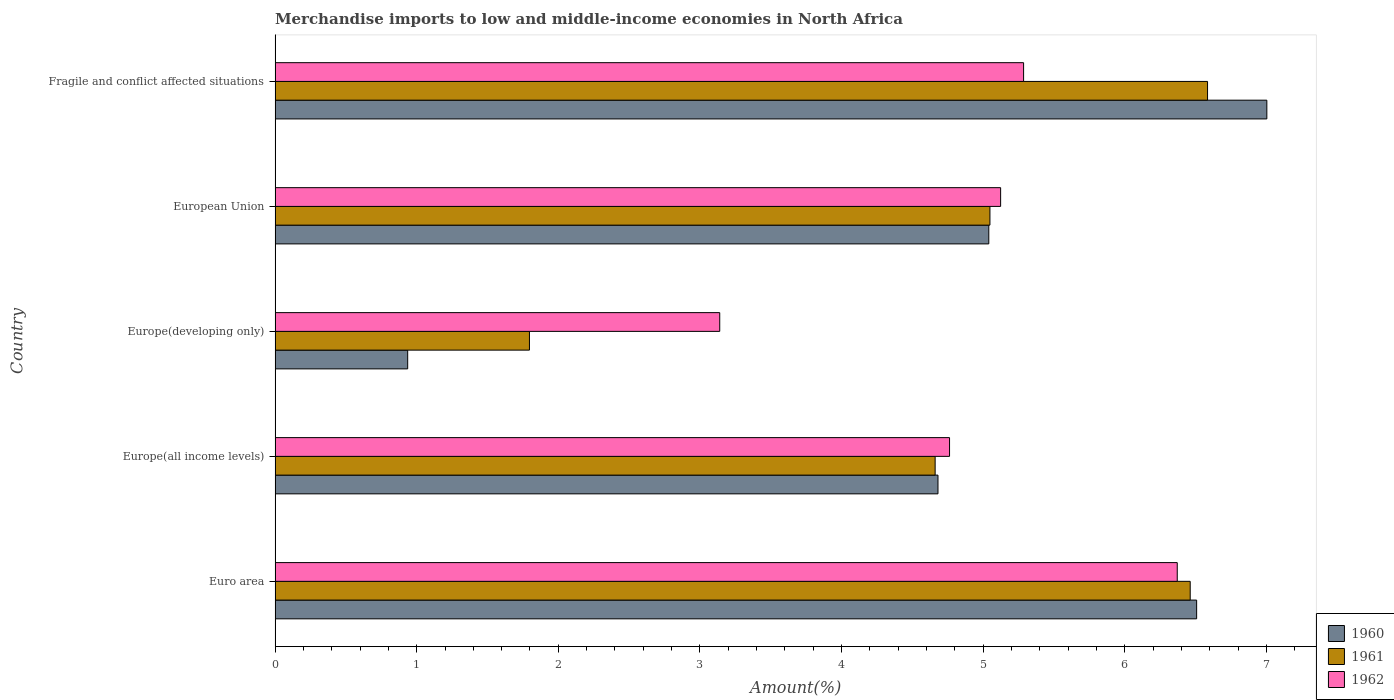How many different coloured bars are there?
Offer a very short reply. 3. How many groups of bars are there?
Your response must be concise. 5. Are the number of bars on each tick of the Y-axis equal?
Keep it short and to the point. Yes. What is the label of the 4th group of bars from the top?
Your response must be concise. Europe(all income levels). In how many cases, is the number of bars for a given country not equal to the number of legend labels?
Offer a terse response. 0. What is the percentage of amount earned from merchandise imports in 1962 in Fragile and conflict affected situations?
Ensure brevity in your answer.  5.29. Across all countries, what is the maximum percentage of amount earned from merchandise imports in 1960?
Your response must be concise. 7. Across all countries, what is the minimum percentage of amount earned from merchandise imports in 1962?
Your answer should be very brief. 3.14. In which country was the percentage of amount earned from merchandise imports in 1961 maximum?
Keep it short and to the point. Fragile and conflict affected situations. In which country was the percentage of amount earned from merchandise imports in 1961 minimum?
Make the answer very short. Europe(developing only). What is the total percentage of amount earned from merchandise imports in 1961 in the graph?
Provide a short and direct response. 24.55. What is the difference between the percentage of amount earned from merchandise imports in 1961 in Euro area and that in European Union?
Keep it short and to the point. 1.41. What is the difference between the percentage of amount earned from merchandise imports in 1962 in Euro area and the percentage of amount earned from merchandise imports in 1961 in Fragile and conflict affected situations?
Your response must be concise. -0.21. What is the average percentage of amount earned from merchandise imports in 1960 per country?
Your answer should be compact. 4.83. What is the difference between the percentage of amount earned from merchandise imports in 1961 and percentage of amount earned from merchandise imports in 1962 in Euro area?
Your answer should be very brief. 0.09. What is the ratio of the percentage of amount earned from merchandise imports in 1960 in Europe(developing only) to that in European Union?
Your answer should be very brief. 0.19. Is the percentage of amount earned from merchandise imports in 1961 in Europe(developing only) less than that in European Union?
Provide a short and direct response. Yes. What is the difference between the highest and the second highest percentage of amount earned from merchandise imports in 1962?
Give a very brief answer. 1.08. What is the difference between the highest and the lowest percentage of amount earned from merchandise imports in 1962?
Provide a short and direct response. 3.23. In how many countries, is the percentage of amount earned from merchandise imports in 1960 greater than the average percentage of amount earned from merchandise imports in 1960 taken over all countries?
Your response must be concise. 3. What does the 1st bar from the top in European Union represents?
Provide a succinct answer. 1962. What does the 2nd bar from the bottom in Europe(all income levels) represents?
Keep it short and to the point. 1961. Is it the case that in every country, the sum of the percentage of amount earned from merchandise imports in 1960 and percentage of amount earned from merchandise imports in 1961 is greater than the percentage of amount earned from merchandise imports in 1962?
Your answer should be very brief. No. What is the difference between two consecutive major ticks on the X-axis?
Make the answer very short. 1. Does the graph contain any zero values?
Your answer should be very brief. No. Where does the legend appear in the graph?
Make the answer very short. Bottom right. How are the legend labels stacked?
Your response must be concise. Vertical. What is the title of the graph?
Your answer should be very brief. Merchandise imports to low and middle-income economies in North Africa. Does "2000" appear as one of the legend labels in the graph?
Make the answer very short. No. What is the label or title of the X-axis?
Give a very brief answer. Amount(%). What is the Amount(%) of 1960 in Euro area?
Offer a terse response. 6.51. What is the Amount(%) of 1961 in Euro area?
Your answer should be very brief. 6.46. What is the Amount(%) of 1962 in Euro area?
Ensure brevity in your answer.  6.37. What is the Amount(%) in 1960 in Europe(all income levels)?
Ensure brevity in your answer.  4.68. What is the Amount(%) in 1961 in Europe(all income levels)?
Offer a very short reply. 4.66. What is the Amount(%) of 1962 in Europe(all income levels)?
Offer a very short reply. 4.76. What is the Amount(%) in 1960 in Europe(developing only)?
Ensure brevity in your answer.  0.94. What is the Amount(%) of 1961 in Europe(developing only)?
Provide a short and direct response. 1.8. What is the Amount(%) of 1962 in Europe(developing only)?
Make the answer very short. 3.14. What is the Amount(%) in 1960 in European Union?
Keep it short and to the point. 5.04. What is the Amount(%) of 1961 in European Union?
Your response must be concise. 5.05. What is the Amount(%) in 1962 in European Union?
Provide a short and direct response. 5.12. What is the Amount(%) of 1960 in Fragile and conflict affected situations?
Your response must be concise. 7. What is the Amount(%) of 1961 in Fragile and conflict affected situations?
Give a very brief answer. 6.58. What is the Amount(%) of 1962 in Fragile and conflict affected situations?
Keep it short and to the point. 5.29. Across all countries, what is the maximum Amount(%) of 1960?
Give a very brief answer. 7. Across all countries, what is the maximum Amount(%) of 1961?
Your response must be concise. 6.58. Across all countries, what is the maximum Amount(%) of 1962?
Make the answer very short. 6.37. Across all countries, what is the minimum Amount(%) of 1960?
Your response must be concise. 0.94. Across all countries, what is the minimum Amount(%) in 1961?
Give a very brief answer. 1.8. Across all countries, what is the minimum Amount(%) in 1962?
Make the answer very short. 3.14. What is the total Amount(%) in 1960 in the graph?
Give a very brief answer. 24.17. What is the total Amount(%) in 1961 in the graph?
Provide a short and direct response. 24.55. What is the total Amount(%) in 1962 in the graph?
Offer a terse response. 24.68. What is the difference between the Amount(%) in 1960 in Euro area and that in Europe(all income levels)?
Ensure brevity in your answer.  1.83. What is the difference between the Amount(%) in 1961 in Euro area and that in Europe(all income levels)?
Give a very brief answer. 1.8. What is the difference between the Amount(%) in 1962 in Euro area and that in Europe(all income levels)?
Keep it short and to the point. 1.61. What is the difference between the Amount(%) of 1960 in Euro area and that in Europe(developing only)?
Ensure brevity in your answer.  5.57. What is the difference between the Amount(%) in 1961 in Euro area and that in Europe(developing only)?
Offer a terse response. 4.67. What is the difference between the Amount(%) of 1962 in Euro area and that in Europe(developing only)?
Your answer should be compact. 3.23. What is the difference between the Amount(%) of 1960 in Euro area and that in European Union?
Your answer should be compact. 1.47. What is the difference between the Amount(%) in 1961 in Euro area and that in European Union?
Give a very brief answer. 1.41. What is the difference between the Amount(%) in 1962 in Euro area and that in European Union?
Make the answer very short. 1.25. What is the difference between the Amount(%) of 1960 in Euro area and that in Fragile and conflict affected situations?
Ensure brevity in your answer.  -0.5. What is the difference between the Amount(%) in 1961 in Euro area and that in Fragile and conflict affected situations?
Provide a short and direct response. -0.12. What is the difference between the Amount(%) of 1962 in Euro area and that in Fragile and conflict affected situations?
Provide a succinct answer. 1.08. What is the difference between the Amount(%) of 1960 in Europe(all income levels) and that in Europe(developing only)?
Keep it short and to the point. 3.74. What is the difference between the Amount(%) of 1961 in Europe(all income levels) and that in Europe(developing only)?
Your answer should be compact. 2.86. What is the difference between the Amount(%) of 1962 in Europe(all income levels) and that in Europe(developing only)?
Keep it short and to the point. 1.62. What is the difference between the Amount(%) in 1960 in Europe(all income levels) and that in European Union?
Provide a succinct answer. -0.36. What is the difference between the Amount(%) of 1961 in Europe(all income levels) and that in European Union?
Keep it short and to the point. -0.39. What is the difference between the Amount(%) in 1962 in Europe(all income levels) and that in European Union?
Make the answer very short. -0.36. What is the difference between the Amount(%) in 1960 in Europe(all income levels) and that in Fragile and conflict affected situations?
Make the answer very short. -2.32. What is the difference between the Amount(%) in 1961 in Europe(all income levels) and that in Fragile and conflict affected situations?
Give a very brief answer. -1.92. What is the difference between the Amount(%) in 1962 in Europe(all income levels) and that in Fragile and conflict affected situations?
Provide a succinct answer. -0.52. What is the difference between the Amount(%) in 1960 in Europe(developing only) and that in European Union?
Your answer should be very brief. -4.1. What is the difference between the Amount(%) in 1961 in Europe(developing only) and that in European Union?
Your answer should be very brief. -3.25. What is the difference between the Amount(%) in 1962 in Europe(developing only) and that in European Union?
Give a very brief answer. -1.98. What is the difference between the Amount(%) in 1960 in Europe(developing only) and that in Fragile and conflict affected situations?
Make the answer very short. -6.07. What is the difference between the Amount(%) in 1961 in Europe(developing only) and that in Fragile and conflict affected situations?
Your response must be concise. -4.79. What is the difference between the Amount(%) of 1962 in Europe(developing only) and that in Fragile and conflict affected situations?
Provide a short and direct response. -2.15. What is the difference between the Amount(%) in 1960 in European Union and that in Fragile and conflict affected situations?
Give a very brief answer. -1.96. What is the difference between the Amount(%) of 1961 in European Union and that in Fragile and conflict affected situations?
Offer a terse response. -1.54. What is the difference between the Amount(%) of 1962 in European Union and that in Fragile and conflict affected situations?
Make the answer very short. -0.16. What is the difference between the Amount(%) in 1960 in Euro area and the Amount(%) in 1961 in Europe(all income levels)?
Offer a terse response. 1.85. What is the difference between the Amount(%) in 1960 in Euro area and the Amount(%) in 1962 in Europe(all income levels)?
Give a very brief answer. 1.74. What is the difference between the Amount(%) in 1961 in Euro area and the Amount(%) in 1962 in Europe(all income levels)?
Your answer should be very brief. 1.7. What is the difference between the Amount(%) of 1960 in Euro area and the Amount(%) of 1961 in Europe(developing only)?
Make the answer very short. 4.71. What is the difference between the Amount(%) of 1960 in Euro area and the Amount(%) of 1962 in Europe(developing only)?
Offer a terse response. 3.37. What is the difference between the Amount(%) of 1961 in Euro area and the Amount(%) of 1962 in Europe(developing only)?
Your answer should be compact. 3.32. What is the difference between the Amount(%) of 1960 in Euro area and the Amount(%) of 1961 in European Union?
Make the answer very short. 1.46. What is the difference between the Amount(%) of 1960 in Euro area and the Amount(%) of 1962 in European Union?
Your answer should be compact. 1.38. What is the difference between the Amount(%) in 1961 in Euro area and the Amount(%) in 1962 in European Union?
Keep it short and to the point. 1.34. What is the difference between the Amount(%) of 1960 in Euro area and the Amount(%) of 1961 in Fragile and conflict affected situations?
Your response must be concise. -0.08. What is the difference between the Amount(%) in 1960 in Euro area and the Amount(%) in 1962 in Fragile and conflict affected situations?
Offer a very short reply. 1.22. What is the difference between the Amount(%) of 1961 in Euro area and the Amount(%) of 1962 in Fragile and conflict affected situations?
Ensure brevity in your answer.  1.18. What is the difference between the Amount(%) of 1960 in Europe(all income levels) and the Amount(%) of 1961 in Europe(developing only)?
Make the answer very short. 2.88. What is the difference between the Amount(%) in 1960 in Europe(all income levels) and the Amount(%) in 1962 in Europe(developing only)?
Give a very brief answer. 1.54. What is the difference between the Amount(%) in 1961 in Europe(all income levels) and the Amount(%) in 1962 in Europe(developing only)?
Keep it short and to the point. 1.52. What is the difference between the Amount(%) in 1960 in Europe(all income levels) and the Amount(%) in 1961 in European Union?
Provide a short and direct response. -0.37. What is the difference between the Amount(%) of 1960 in Europe(all income levels) and the Amount(%) of 1962 in European Union?
Your response must be concise. -0.44. What is the difference between the Amount(%) in 1961 in Europe(all income levels) and the Amount(%) in 1962 in European Union?
Keep it short and to the point. -0.46. What is the difference between the Amount(%) of 1960 in Europe(all income levels) and the Amount(%) of 1961 in Fragile and conflict affected situations?
Make the answer very short. -1.9. What is the difference between the Amount(%) of 1960 in Europe(all income levels) and the Amount(%) of 1962 in Fragile and conflict affected situations?
Your answer should be compact. -0.6. What is the difference between the Amount(%) of 1961 in Europe(all income levels) and the Amount(%) of 1962 in Fragile and conflict affected situations?
Your response must be concise. -0.62. What is the difference between the Amount(%) in 1960 in Europe(developing only) and the Amount(%) in 1961 in European Union?
Provide a succinct answer. -4.11. What is the difference between the Amount(%) of 1960 in Europe(developing only) and the Amount(%) of 1962 in European Union?
Make the answer very short. -4.19. What is the difference between the Amount(%) of 1961 in Europe(developing only) and the Amount(%) of 1962 in European Union?
Offer a very short reply. -3.33. What is the difference between the Amount(%) in 1960 in Europe(developing only) and the Amount(%) in 1961 in Fragile and conflict affected situations?
Your answer should be compact. -5.65. What is the difference between the Amount(%) of 1960 in Europe(developing only) and the Amount(%) of 1962 in Fragile and conflict affected situations?
Make the answer very short. -4.35. What is the difference between the Amount(%) of 1961 in Europe(developing only) and the Amount(%) of 1962 in Fragile and conflict affected situations?
Make the answer very short. -3.49. What is the difference between the Amount(%) of 1960 in European Union and the Amount(%) of 1961 in Fragile and conflict affected situations?
Give a very brief answer. -1.54. What is the difference between the Amount(%) in 1960 in European Union and the Amount(%) in 1962 in Fragile and conflict affected situations?
Your response must be concise. -0.25. What is the difference between the Amount(%) of 1961 in European Union and the Amount(%) of 1962 in Fragile and conflict affected situations?
Provide a succinct answer. -0.24. What is the average Amount(%) in 1960 per country?
Offer a very short reply. 4.83. What is the average Amount(%) of 1961 per country?
Give a very brief answer. 4.91. What is the average Amount(%) of 1962 per country?
Provide a short and direct response. 4.94. What is the difference between the Amount(%) in 1960 and Amount(%) in 1961 in Euro area?
Keep it short and to the point. 0.05. What is the difference between the Amount(%) of 1960 and Amount(%) of 1962 in Euro area?
Your answer should be very brief. 0.14. What is the difference between the Amount(%) of 1961 and Amount(%) of 1962 in Euro area?
Your answer should be compact. 0.09. What is the difference between the Amount(%) of 1960 and Amount(%) of 1961 in Europe(all income levels)?
Provide a succinct answer. 0.02. What is the difference between the Amount(%) in 1960 and Amount(%) in 1962 in Europe(all income levels)?
Offer a terse response. -0.08. What is the difference between the Amount(%) of 1961 and Amount(%) of 1962 in Europe(all income levels)?
Offer a terse response. -0.1. What is the difference between the Amount(%) of 1960 and Amount(%) of 1961 in Europe(developing only)?
Give a very brief answer. -0.86. What is the difference between the Amount(%) in 1960 and Amount(%) in 1962 in Europe(developing only)?
Provide a short and direct response. -2.2. What is the difference between the Amount(%) in 1961 and Amount(%) in 1962 in Europe(developing only)?
Keep it short and to the point. -1.34. What is the difference between the Amount(%) of 1960 and Amount(%) of 1961 in European Union?
Provide a succinct answer. -0.01. What is the difference between the Amount(%) of 1960 and Amount(%) of 1962 in European Union?
Offer a very short reply. -0.08. What is the difference between the Amount(%) of 1961 and Amount(%) of 1962 in European Union?
Your response must be concise. -0.08. What is the difference between the Amount(%) in 1960 and Amount(%) in 1961 in Fragile and conflict affected situations?
Provide a short and direct response. 0.42. What is the difference between the Amount(%) of 1960 and Amount(%) of 1962 in Fragile and conflict affected situations?
Keep it short and to the point. 1.72. What is the difference between the Amount(%) of 1961 and Amount(%) of 1962 in Fragile and conflict affected situations?
Provide a succinct answer. 1.3. What is the ratio of the Amount(%) of 1960 in Euro area to that in Europe(all income levels)?
Provide a short and direct response. 1.39. What is the ratio of the Amount(%) in 1961 in Euro area to that in Europe(all income levels)?
Your response must be concise. 1.39. What is the ratio of the Amount(%) in 1962 in Euro area to that in Europe(all income levels)?
Your answer should be compact. 1.34. What is the ratio of the Amount(%) of 1960 in Euro area to that in Europe(developing only)?
Offer a terse response. 6.95. What is the ratio of the Amount(%) in 1961 in Euro area to that in Europe(developing only)?
Offer a terse response. 3.6. What is the ratio of the Amount(%) in 1962 in Euro area to that in Europe(developing only)?
Make the answer very short. 2.03. What is the ratio of the Amount(%) in 1960 in Euro area to that in European Union?
Your response must be concise. 1.29. What is the ratio of the Amount(%) of 1961 in Euro area to that in European Union?
Your answer should be very brief. 1.28. What is the ratio of the Amount(%) of 1962 in Euro area to that in European Union?
Your answer should be compact. 1.24. What is the ratio of the Amount(%) of 1960 in Euro area to that in Fragile and conflict affected situations?
Offer a very short reply. 0.93. What is the ratio of the Amount(%) of 1961 in Euro area to that in Fragile and conflict affected situations?
Offer a terse response. 0.98. What is the ratio of the Amount(%) of 1962 in Euro area to that in Fragile and conflict affected situations?
Ensure brevity in your answer.  1.21. What is the ratio of the Amount(%) in 1960 in Europe(all income levels) to that in Europe(developing only)?
Offer a terse response. 5. What is the ratio of the Amount(%) of 1961 in Europe(all income levels) to that in Europe(developing only)?
Your response must be concise. 2.59. What is the ratio of the Amount(%) in 1962 in Europe(all income levels) to that in Europe(developing only)?
Make the answer very short. 1.52. What is the ratio of the Amount(%) of 1960 in Europe(all income levels) to that in European Union?
Your response must be concise. 0.93. What is the ratio of the Amount(%) of 1961 in Europe(all income levels) to that in European Union?
Ensure brevity in your answer.  0.92. What is the ratio of the Amount(%) of 1962 in Europe(all income levels) to that in European Union?
Offer a very short reply. 0.93. What is the ratio of the Amount(%) in 1960 in Europe(all income levels) to that in Fragile and conflict affected situations?
Provide a short and direct response. 0.67. What is the ratio of the Amount(%) in 1961 in Europe(all income levels) to that in Fragile and conflict affected situations?
Give a very brief answer. 0.71. What is the ratio of the Amount(%) of 1962 in Europe(all income levels) to that in Fragile and conflict affected situations?
Provide a short and direct response. 0.9. What is the ratio of the Amount(%) of 1960 in Europe(developing only) to that in European Union?
Ensure brevity in your answer.  0.19. What is the ratio of the Amount(%) in 1961 in Europe(developing only) to that in European Union?
Your response must be concise. 0.36. What is the ratio of the Amount(%) in 1962 in Europe(developing only) to that in European Union?
Keep it short and to the point. 0.61. What is the ratio of the Amount(%) in 1960 in Europe(developing only) to that in Fragile and conflict affected situations?
Your answer should be very brief. 0.13. What is the ratio of the Amount(%) of 1961 in Europe(developing only) to that in Fragile and conflict affected situations?
Ensure brevity in your answer.  0.27. What is the ratio of the Amount(%) in 1962 in Europe(developing only) to that in Fragile and conflict affected situations?
Your response must be concise. 0.59. What is the ratio of the Amount(%) in 1960 in European Union to that in Fragile and conflict affected situations?
Give a very brief answer. 0.72. What is the ratio of the Amount(%) of 1961 in European Union to that in Fragile and conflict affected situations?
Make the answer very short. 0.77. What is the ratio of the Amount(%) of 1962 in European Union to that in Fragile and conflict affected situations?
Ensure brevity in your answer.  0.97. What is the difference between the highest and the second highest Amount(%) in 1960?
Your response must be concise. 0.5. What is the difference between the highest and the second highest Amount(%) in 1961?
Give a very brief answer. 0.12. What is the difference between the highest and the second highest Amount(%) of 1962?
Provide a succinct answer. 1.08. What is the difference between the highest and the lowest Amount(%) of 1960?
Ensure brevity in your answer.  6.07. What is the difference between the highest and the lowest Amount(%) of 1961?
Your response must be concise. 4.79. What is the difference between the highest and the lowest Amount(%) of 1962?
Make the answer very short. 3.23. 